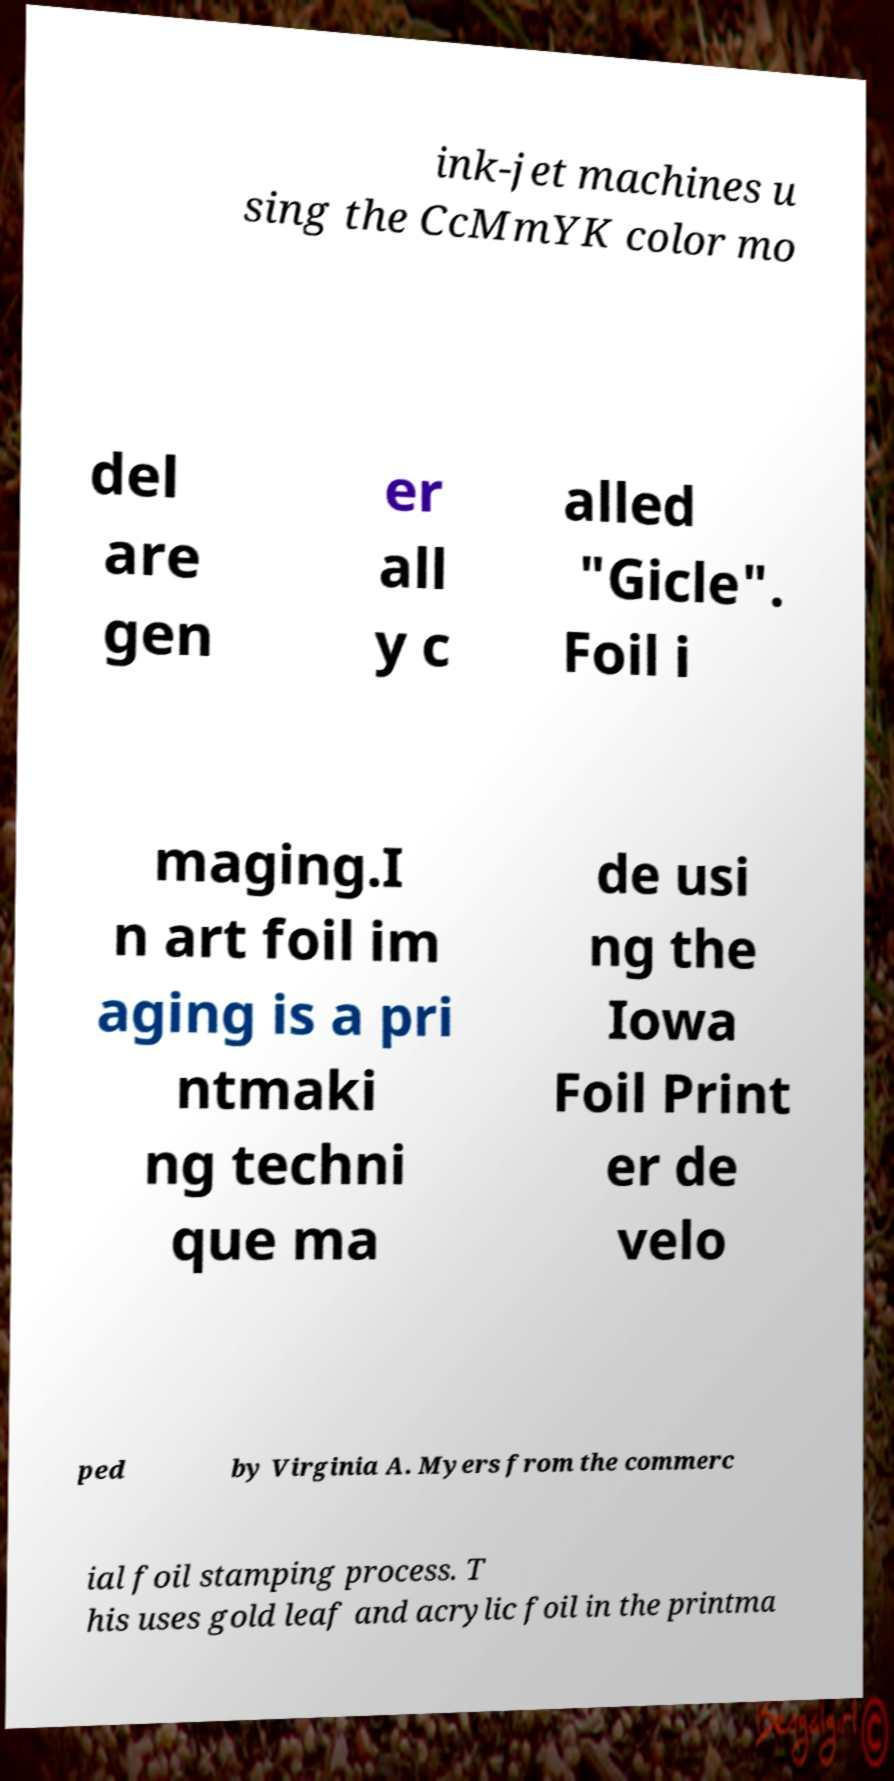Please read and relay the text visible in this image. What does it say? ink-jet machines u sing the CcMmYK color mo del are gen er all y c alled "Gicle". Foil i maging.I n art foil im aging is a pri ntmaki ng techni que ma de usi ng the Iowa Foil Print er de velo ped by Virginia A. Myers from the commerc ial foil stamping process. T his uses gold leaf and acrylic foil in the printma 